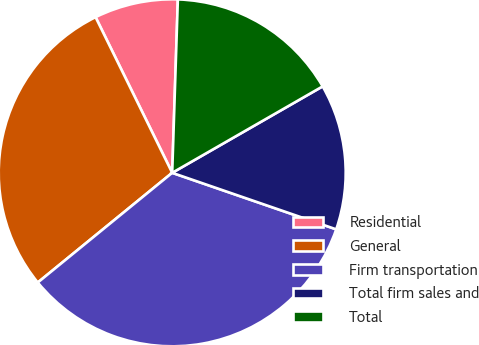Convert chart to OTSL. <chart><loc_0><loc_0><loc_500><loc_500><pie_chart><fcel>Residential<fcel>General<fcel>Firm transportation<fcel>Total firm sales and<fcel>Total<nl><fcel>7.8%<fcel>28.61%<fcel>33.82%<fcel>13.58%<fcel>16.18%<nl></chart> 